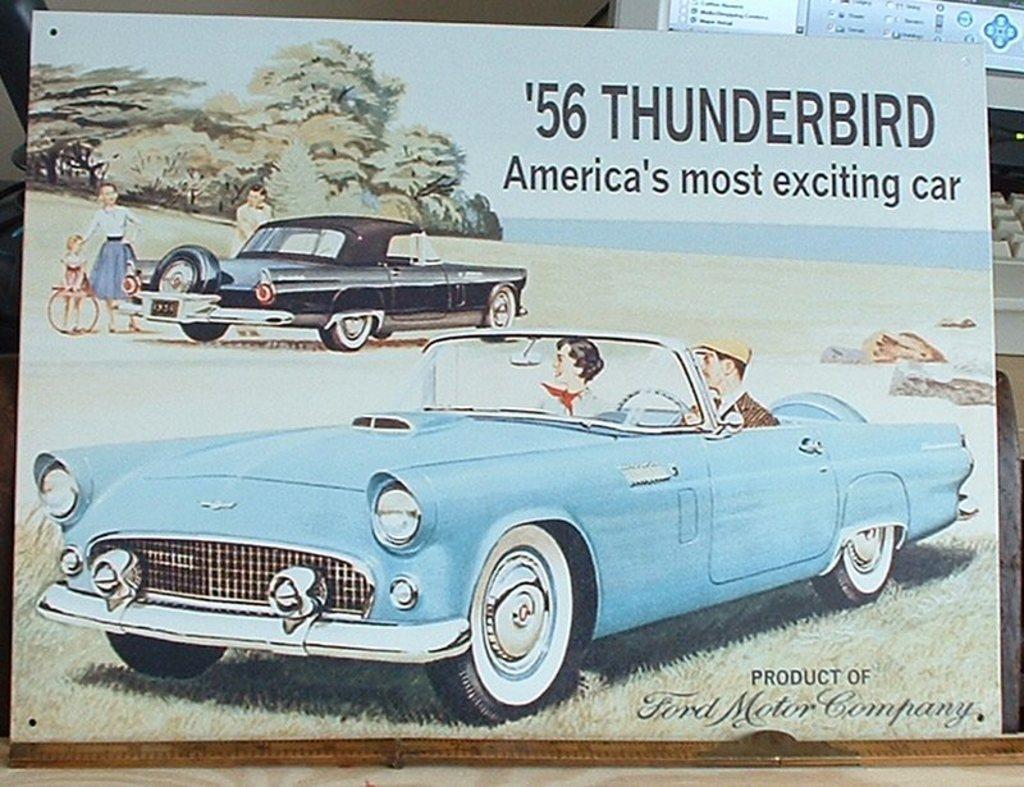How would you summarize this image in a sentence or two? In the image there is cartoon picture of two cars and some people and behind that image there is a computer. 